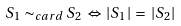<formula> <loc_0><loc_0><loc_500><loc_500>S _ { 1 } \sim _ { c a r d } S _ { 2 } \, \Leftrightarrow \, | S _ { 1 } | \, = \, | S _ { 2 } |</formula> 